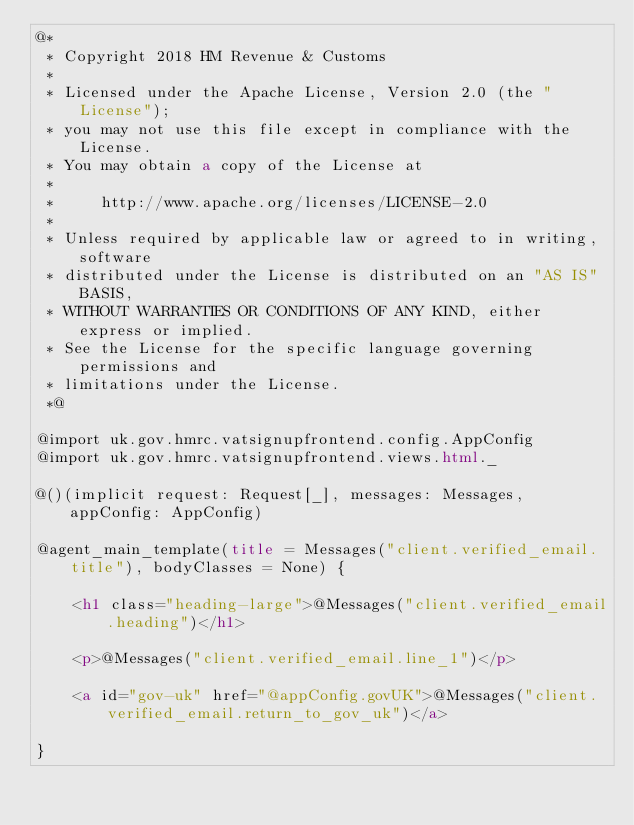<code> <loc_0><loc_0><loc_500><loc_500><_HTML_>@*
 * Copyright 2018 HM Revenue & Customs
 *
 * Licensed under the Apache License, Version 2.0 (the "License");
 * you may not use this file except in compliance with the License.
 * You may obtain a copy of the License at
 *
 *     http://www.apache.org/licenses/LICENSE-2.0
 *
 * Unless required by applicable law or agreed to in writing, software
 * distributed under the License is distributed on an "AS IS" BASIS,
 * WITHOUT WARRANTIES OR CONDITIONS OF ANY KIND, either express or implied.
 * See the License for the specific language governing permissions and
 * limitations under the License.
 *@

@import uk.gov.hmrc.vatsignupfrontend.config.AppConfig
@import uk.gov.hmrc.vatsignupfrontend.views.html._

@()(implicit request: Request[_], messages: Messages, appConfig: AppConfig)

@agent_main_template(title = Messages("client.verified_email.title"), bodyClasses = None) {

    <h1 class="heading-large">@Messages("client.verified_email.heading")</h1>

    <p>@Messages("client.verified_email.line_1")</p>

    <a id="gov-uk" href="@appConfig.govUK">@Messages("client.verified_email.return_to_gov_uk")</a>

}
</code> 